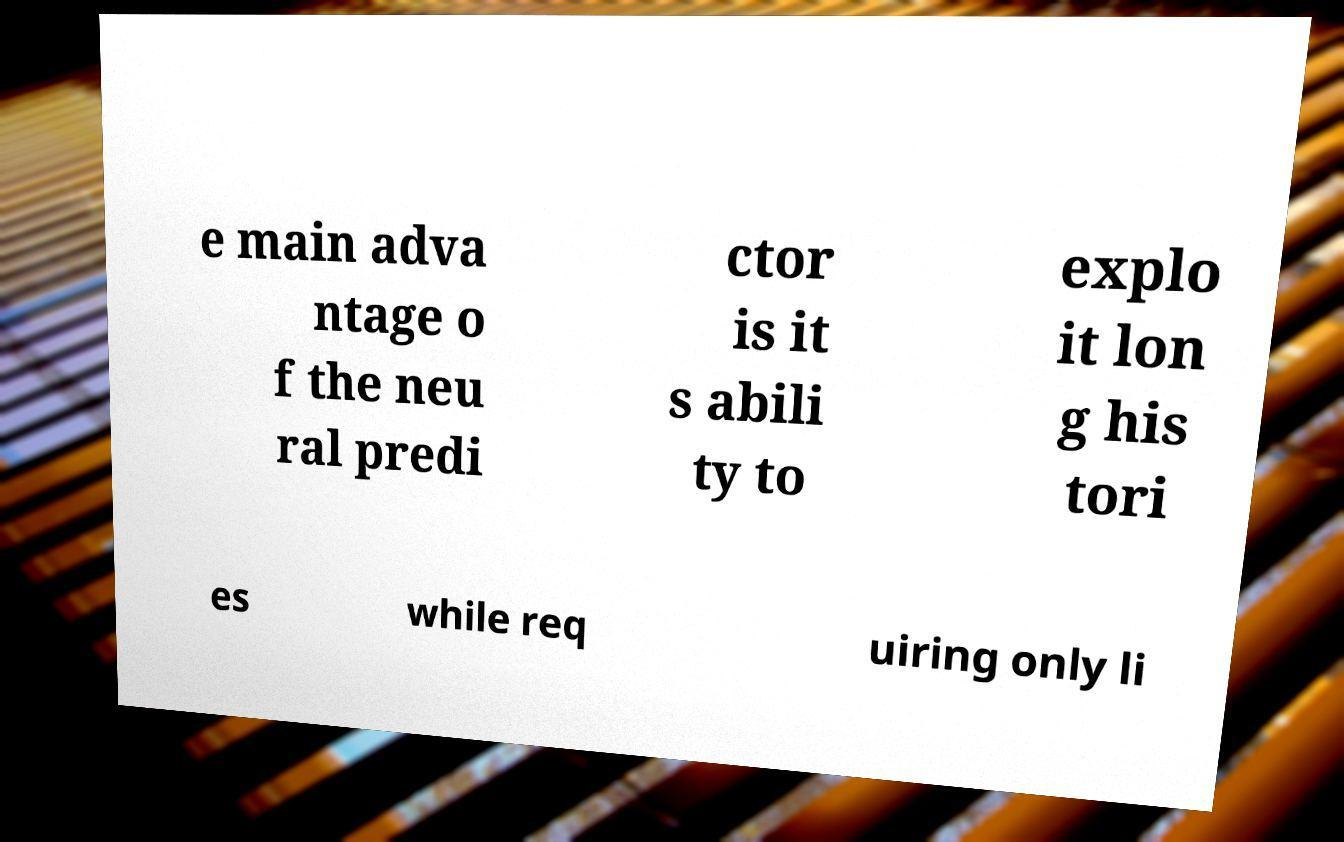For documentation purposes, I need the text within this image transcribed. Could you provide that? e main adva ntage o f the neu ral predi ctor is it s abili ty to explo it lon g his tori es while req uiring only li 